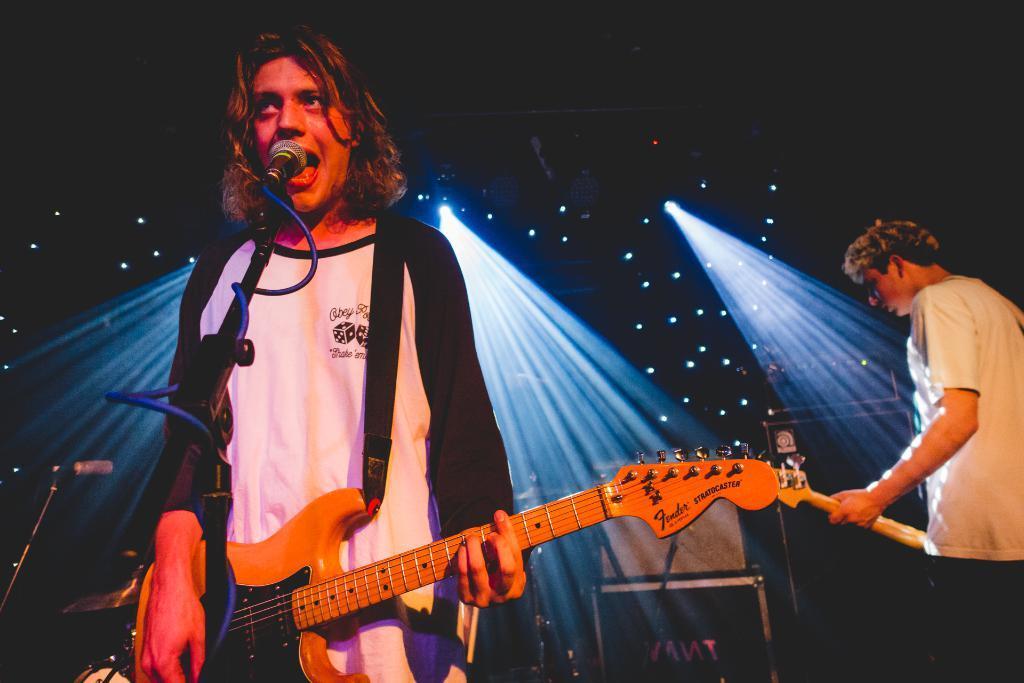In one or two sentences, can you explain what this image depicts? This is man is standing and singing a song as well as he is playing guitar. At the right side of the image I can see another man standing and holding guitar. These are the stage shows. This is a mike with the mike stand. 